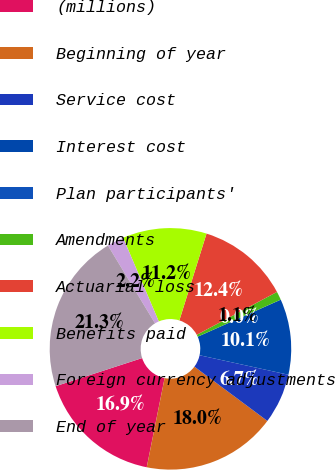<chart> <loc_0><loc_0><loc_500><loc_500><pie_chart><fcel>(millions)<fcel>Beginning of year<fcel>Service cost<fcel>Interest cost<fcel>Plan participants'<fcel>Amendments<fcel>Actuarial loss<fcel>Benefits paid<fcel>Foreign currency adjustments<fcel>End of year<nl><fcel>16.85%<fcel>17.97%<fcel>6.74%<fcel>10.11%<fcel>0.01%<fcel>1.13%<fcel>12.36%<fcel>11.24%<fcel>2.25%<fcel>21.34%<nl></chart> 